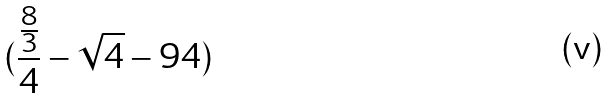<formula> <loc_0><loc_0><loc_500><loc_500>( \frac { \frac { 8 } { 3 } } { 4 } - \sqrt { 4 } - 9 4 )</formula> 